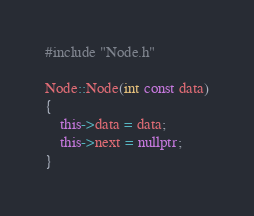Convert code to text. <code><loc_0><loc_0><loc_500><loc_500><_C++_>#include "Node.h"

Node::Node(int const data)
{
	this->data = data;
	this->next = nullptr;
}</code> 